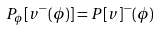Convert formula to latex. <formula><loc_0><loc_0><loc_500><loc_500>P _ { \phi } [ v ^ { - } ( \phi ) ] = P [ v ] ^ { - } ( \phi )</formula> 